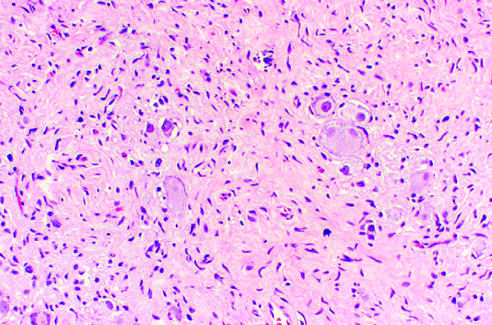what are presented in the background stroma?
Answer the question using a single word or phrase. Spindle-shaped schwann cells 